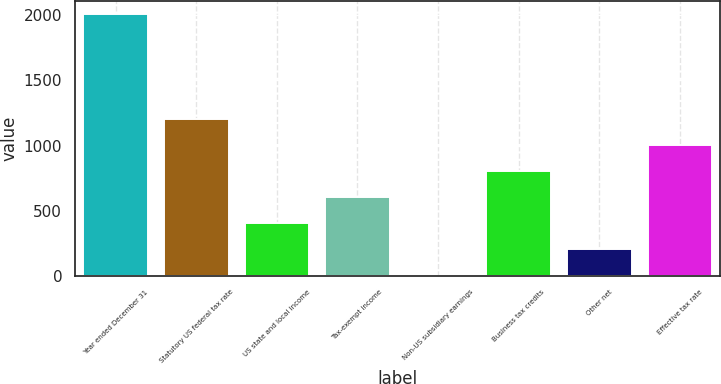Convert chart to OTSL. <chart><loc_0><loc_0><loc_500><loc_500><bar_chart><fcel>Year ended December 31<fcel>Statutory US federal tax rate<fcel>US state and local income<fcel>Tax-exempt income<fcel>Non-US subsidiary earnings<fcel>Business tax credits<fcel>Other net<fcel>Effective tax rate<nl><fcel>2007<fcel>1204.64<fcel>402.28<fcel>602.87<fcel>1.1<fcel>803.46<fcel>201.69<fcel>1004.05<nl></chart> 